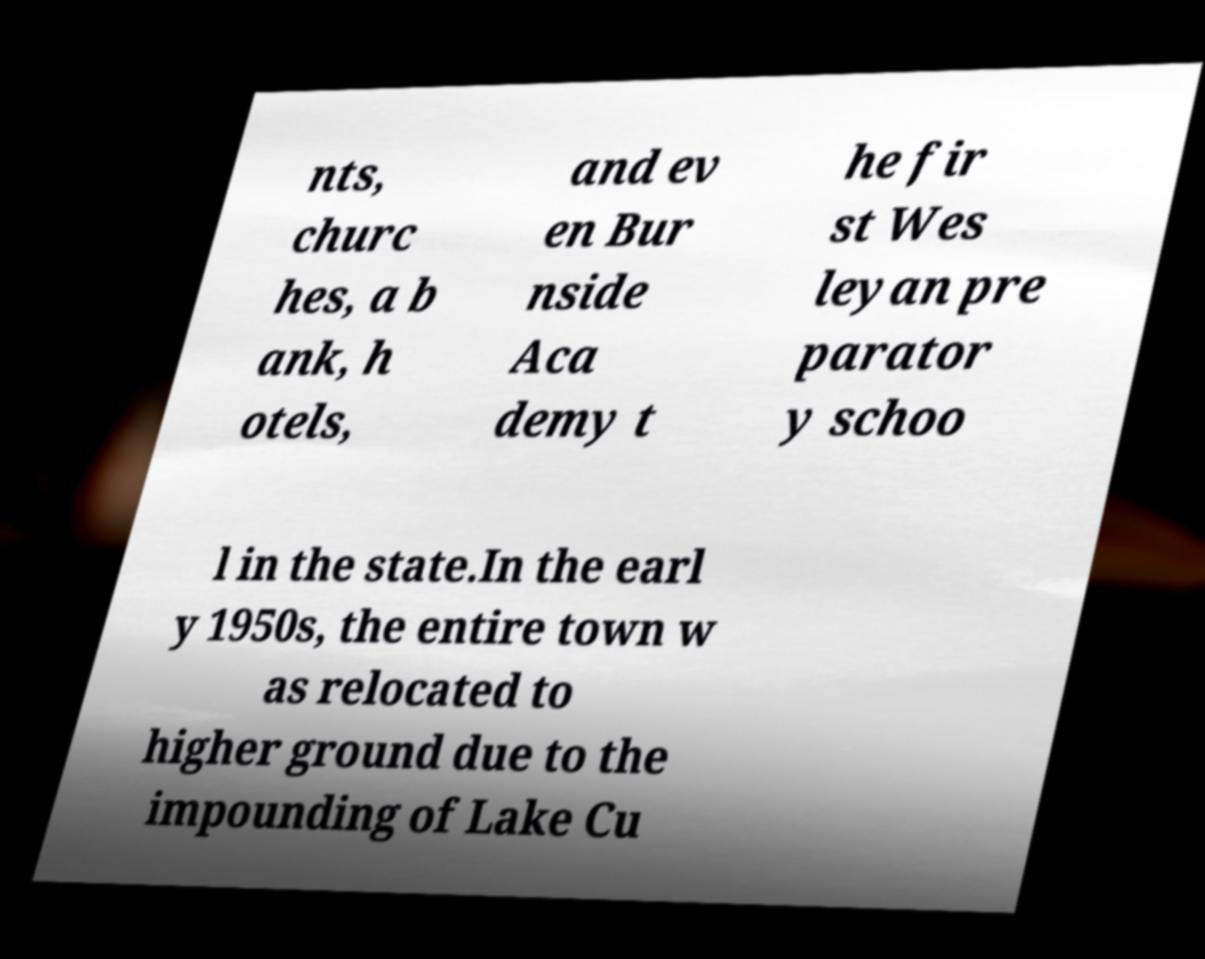I need the written content from this picture converted into text. Can you do that? nts, churc hes, a b ank, h otels, and ev en Bur nside Aca demy t he fir st Wes leyan pre parator y schoo l in the state.In the earl y 1950s, the entire town w as relocated to higher ground due to the impounding of Lake Cu 